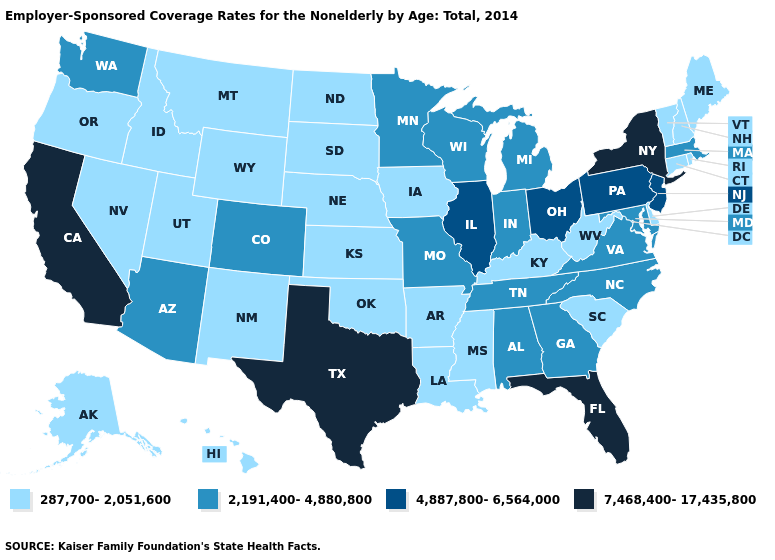Is the legend a continuous bar?
Answer briefly. No. What is the value of Ohio?
Keep it brief. 4,887,800-6,564,000. What is the lowest value in states that border Oregon?
Give a very brief answer. 287,700-2,051,600. What is the value of Delaware?
Write a very short answer. 287,700-2,051,600. What is the value of New York?
Be succinct. 7,468,400-17,435,800. What is the value of Iowa?
Be succinct. 287,700-2,051,600. Is the legend a continuous bar?
Give a very brief answer. No. What is the highest value in the South ?
Short answer required. 7,468,400-17,435,800. What is the lowest value in the USA?
Short answer required. 287,700-2,051,600. Name the states that have a value in the range 287,700-2,051,600?
Short answer required. Alaska, Arkansas, Connecticut, Delaware, Hawaii, Idaho, Iowa, Kansas, Kentucky, Louisiana, Maine, Mississippi, Montana, Nebraska, Nevada, New Hampshire, New Mexico, North Dakota, Oklahoma, Oregon, Rhode Island, South Carolina, South Dakota, Utah, Vermont, West Virginia, Wyoming. Does the first symbol in the legend represent the smallest category?
Concise answer only. Yes. Name the states that have a value in the range 287,700-2,051,600?
Keep it brief. Alaska, Arkansas, Connecticut, Delaware, Hawaii, Idaho, Iowa, Kansas, Kentucky, Louisiana, Maine, Mississippi, Montana, Nebraska, Nevada, New Hampshire, New Mexico, North Dakota, Oklahoma, Oregon, Rhode Island, South Carolina, South Dakota, Utah, Vermont, West Virginia, Wyoming. What is the value of New Jersey?
Be succinct. 4,887,800-6,564,000. Among the states that border California , which have the lowest value?
Be succinct. Nevada, Oregon. 